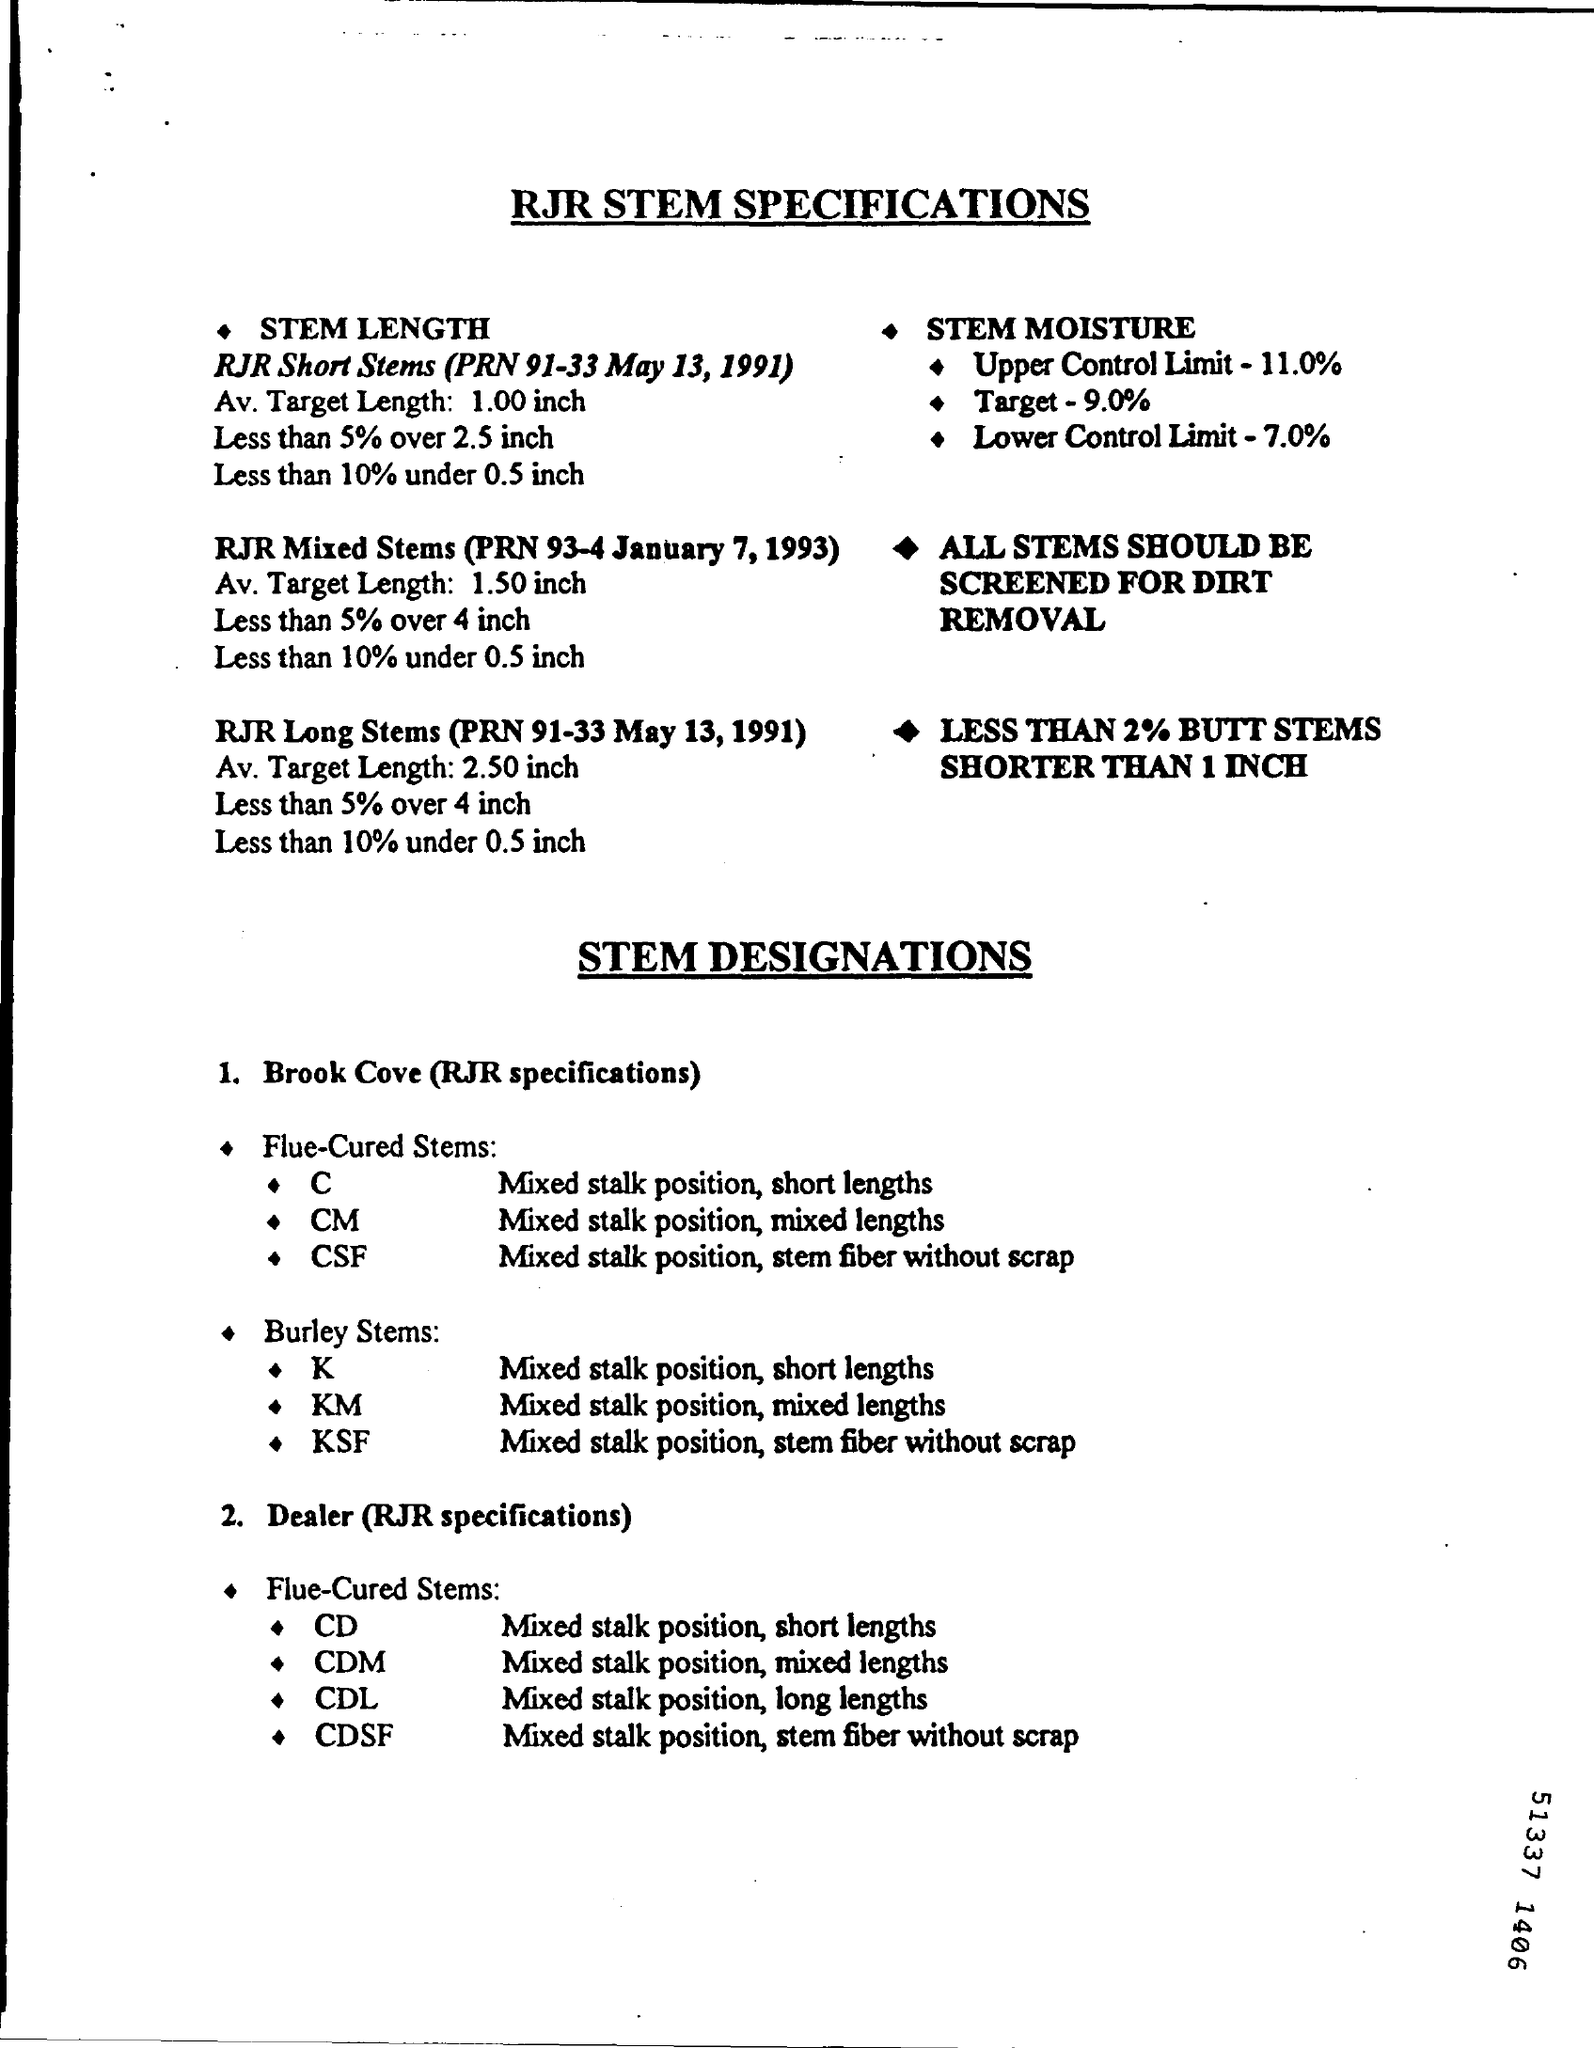Give some essential details in this illustration. The upper control limit of STEM moisture was 11.0%. The RJR specification for Burley Stems KM is for mixed stalk position and mixed lengths. The RJR specification for Brook Cove Flue-Cured Stems C refers to the quality standards for mixed stalk position, short lengths of tobacco leaves. The document title is: "What is the document title? RJR STEM SPECIFICATIONS... 